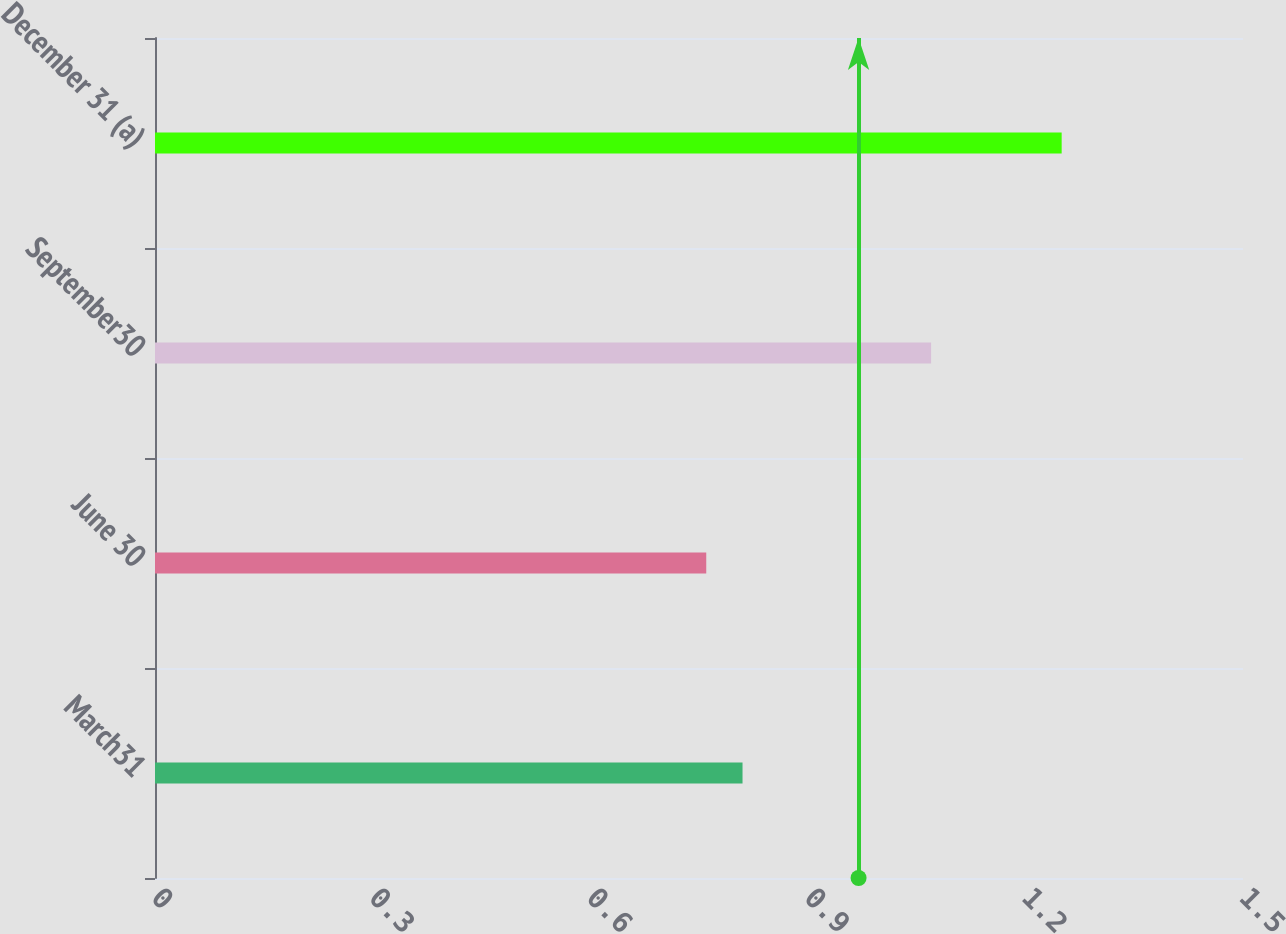<chart> <loc_0><loc_0><loc_500><loc_500><bar_chart><fcel>March31<fcel>June 30<fcel>September30<fcel>December 31 (a)<nl><fcel>0.81<fcel>0.76<fcel>1.07<fcel>1.25<nl></chart> 